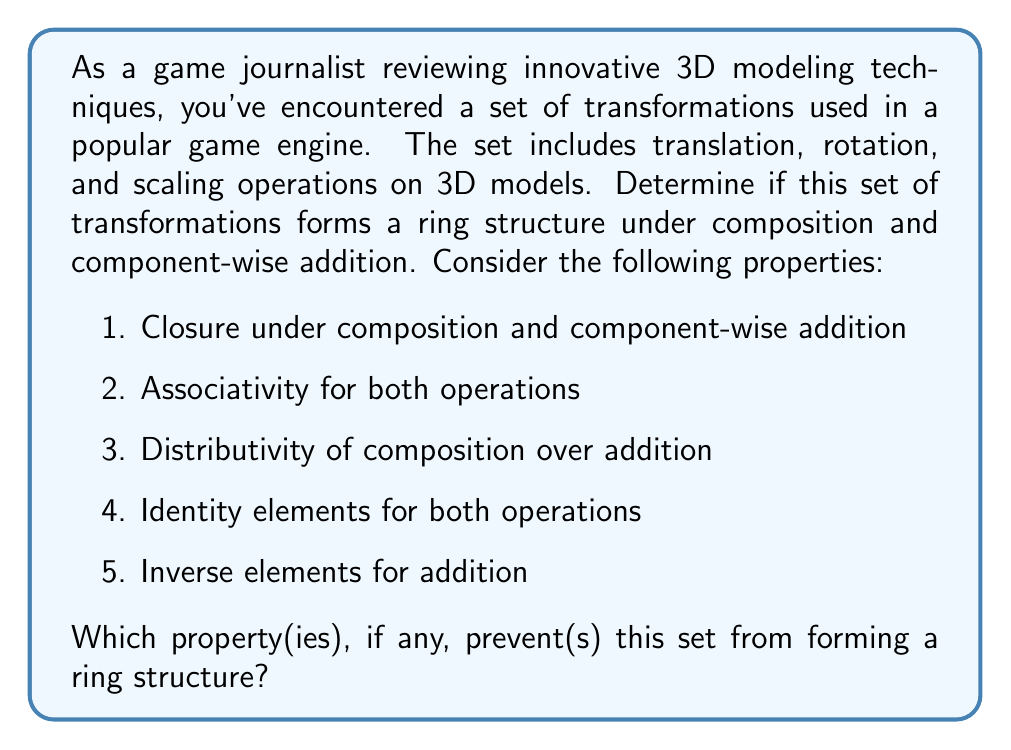Could you help me with this problem? Let's analyze each property of a ring for the given set of 3D transformations:

1. Closure:
   - Composition: The composition of any two 3D transformations results in another 3D transformation. ✓
   - Component-wise addition: Adding two transformations component-wise also results in a valid transformation. ✓

2. Associativity:
   - Composition: $$(A \circ B) \circ C = A \circ (B \circ C)$$ holds for 3D transformations. ✓
   - Component-wise addition: $$(A + B) + C = A + (B + C)$$ holds. ✓

3. Distributivity:
   $A \circ (B + C) = (A \circ B) + (A \circ C)$ and $(B + C) \circ A = (B \circ A) + (C \circ A)$ do not hold in general for 3D transformations. ✗

4. Identity elements:
   - Composition: The identity transformation (no change) serves as the identity. ✓
   - Component-wise addition: The zero transformation (adding 0 to each component) serves as the identity. ✓

5. Inverse elements:
   - Component-wise addition: For each transformation, there exists an inverse transformation that, when added component-wise, results in the zero transformation. ✓

The key issue here is the lack of distributivity. In 3D transformations:

- Translation followed by scaling is not equivalent to scaling followed by translation.
- Rotation followed by translation is not equivalent to translation followed by rotation.

These non-commutative properties violate the distributivity law, which is essential for a ring structure.
Answer: The property that prevents this set of 3D transformations from forming a ring structure is the lack of distributivity of composition over component-wise addition. 